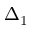Convert formula to latex. <formula><loc_0><loc_0><loc_500><loc_500>\Delta _ { 1 }</formula> 